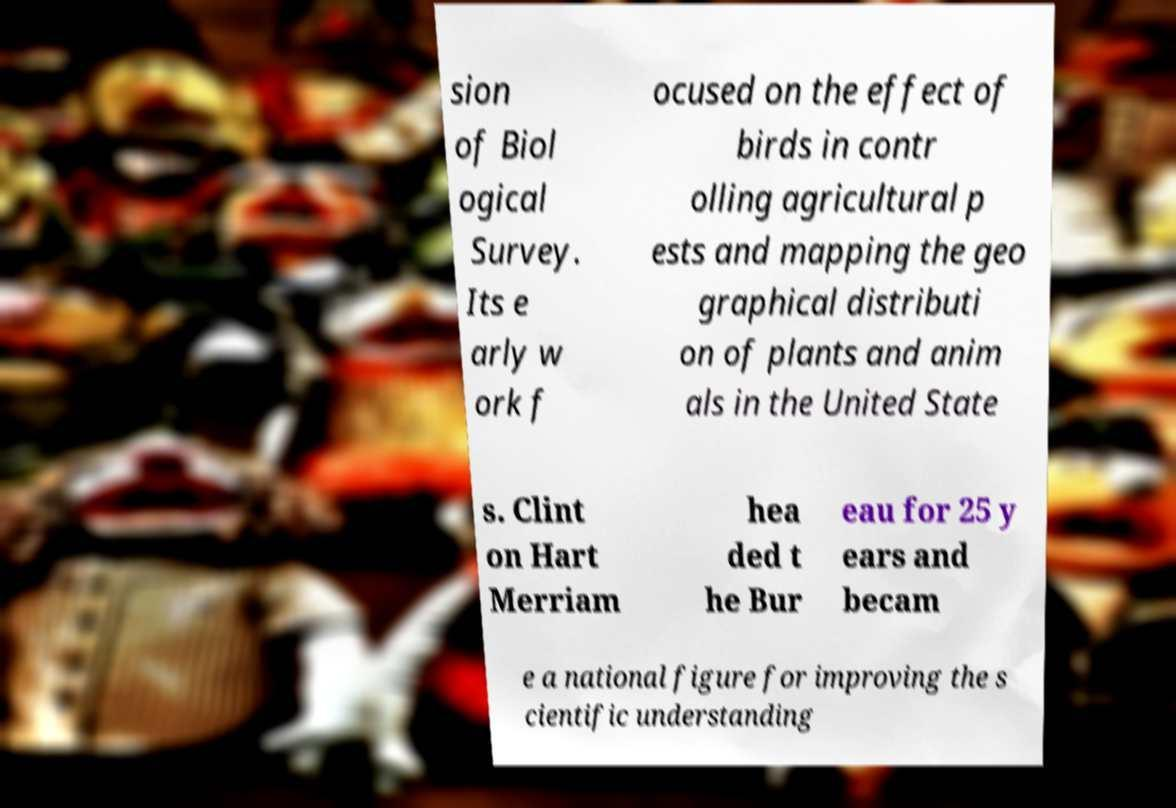Please read and relay the text visible in this image. What does it say? sion of Biol ogical Survey. Its e arly w ork f ocused on the effect of birds in contr olling agricultural p ests and mapping the geo graphical distributi on of plants and anim als in the United State s. Clint on Hart Merriam hea ded t he Bur eau for 25 y ears and becam e a national figure for improving the s cientific understanding 